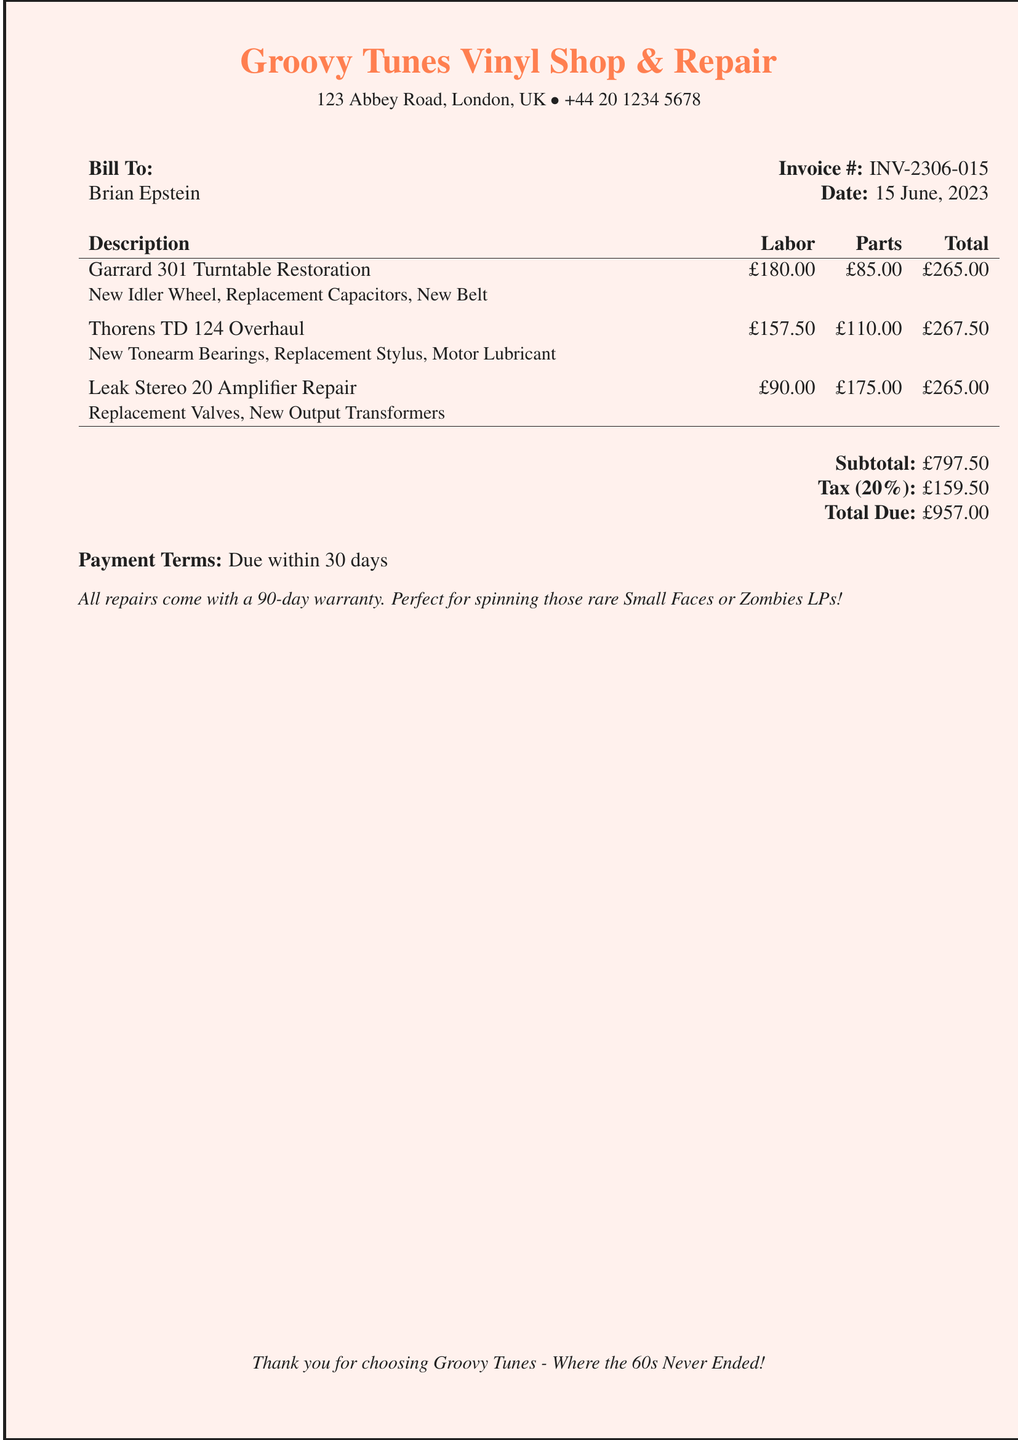What is the invoice number? The invoice number is listed in the document for identification purposes.
Answer: INV-2306-015 What is the total due amount? The total due is calculated after including all parts and labor charges along with tax.
Answer: £957.00 Who is the bill addressed to? The document specifies the recipient of the bill in the "Bill To" section.
Answer: Brian Epstein What is the subtotal before tax? The subtotal is the sum of all charges before applying tax.
Answer: £797.50 What date was the invoice issued? The date of issue is noted in the document's header section.
Answer: 15 June, 2023 What warranty period comes with the repairs? The warranty period for the repairs is mentioned in the document.
Answer: 90-day warranty How much was spent on parts for the Garrard 301 Turntable Restoration? The cost for parts is specified next to the description for each service.
Answer: £85.00 What was the labor cost for the Thorens TD 124 Overhaul? The labor cost is shown in the table next to the description of the service.
Answer: £157.50 What is the tax rate applied to the subtotal? The tax rate is indicated in the subtotal section next to the tax amount.
Answer: 20% 